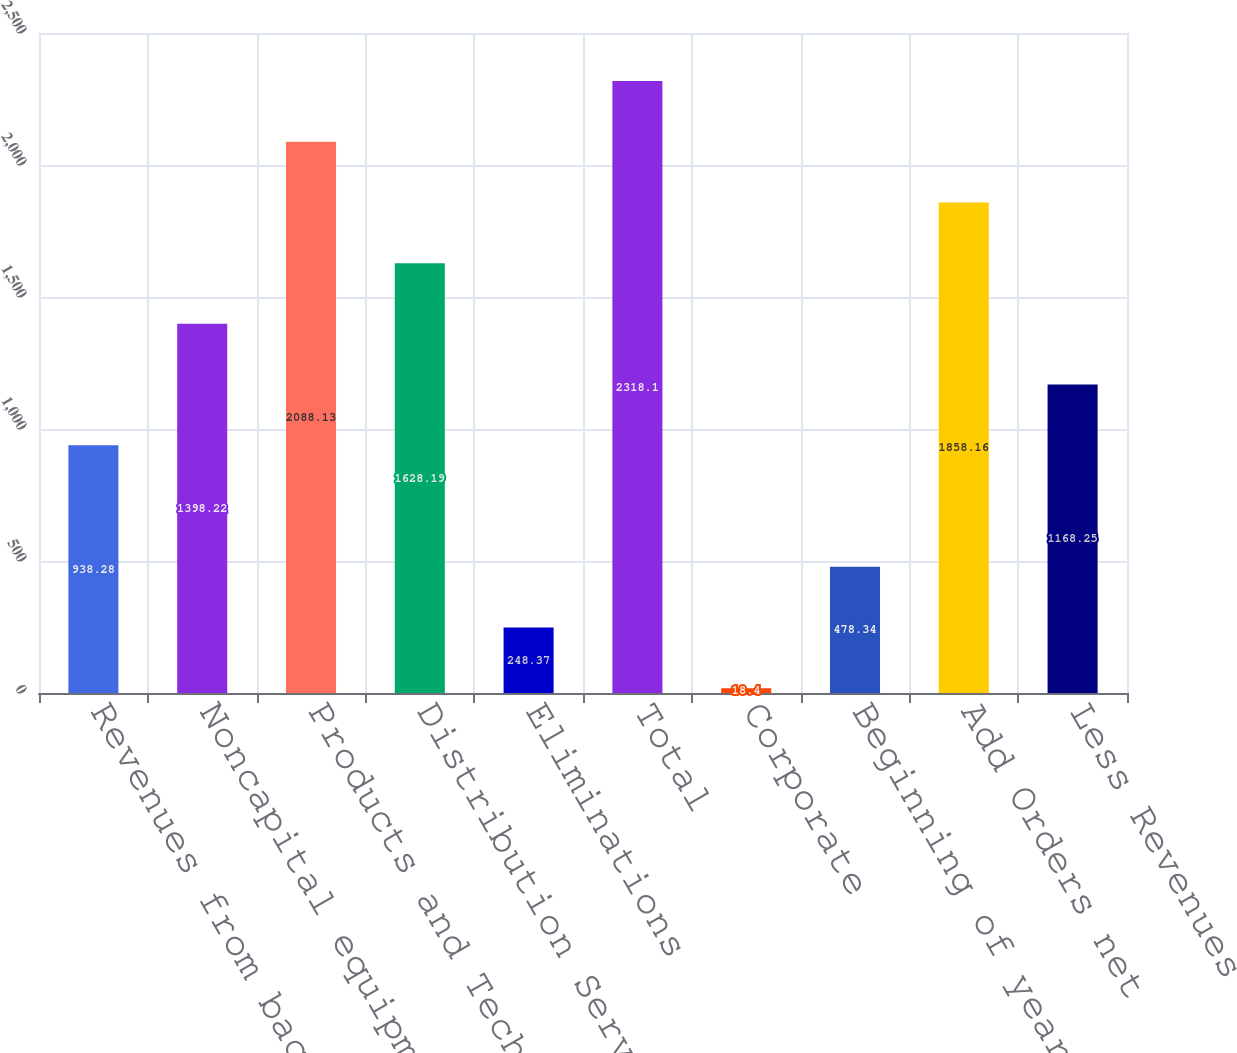Convert chart. <chart><loc_0><loc_0><loc_500><loc_500><bar_chart><fcel>Revenues from backlog<fcel>Noncapital equipment<fcel>Products and Technology<fcel>Distribution Services<fcel>Eliminations<fcel>Total<fcel>Corporate<fcel>Beginning of year<fcel>Add Orders net<fcel>Less Revenues<nl><fcel>938.28<fcel>1398.22<fcel>2088.13<fcel>1628.19<fcel>248.37<fcel>2318.1<fcel>18.4<fcel>478.34<fcel>1858.16<fcel>1168.25<nl></chart> 